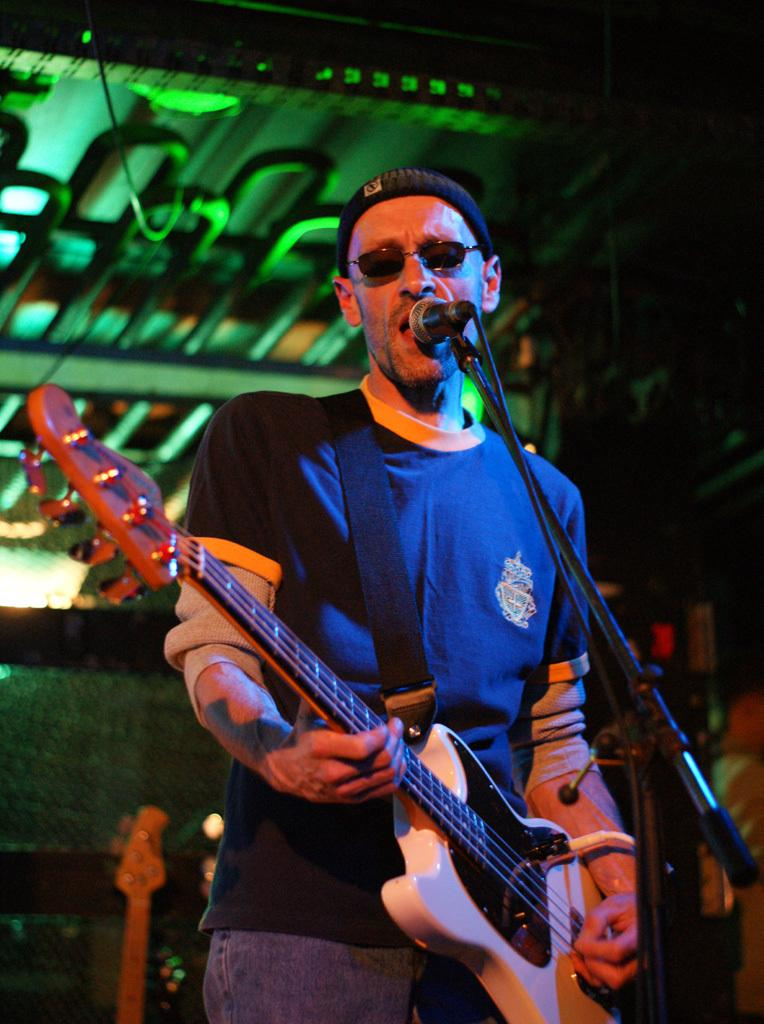What is the person in the image holding? The person is holding a guitar. What is the person likely to be doing with the guitar? The person might be playing or performing with the guitar. What equipment is present for amplifying sound in the image? There is a microphone and a microphone stand in the image. What can be seen in the background of the image? There are objects visible in the background. What type of lighting is present in the image? Green color lighting is present in the image. How many wings does the person have in the image? The person does not have any wings in the image; they are a human with two arms. What type of currency is visible in the image? There is no money or currency visible in the image. 